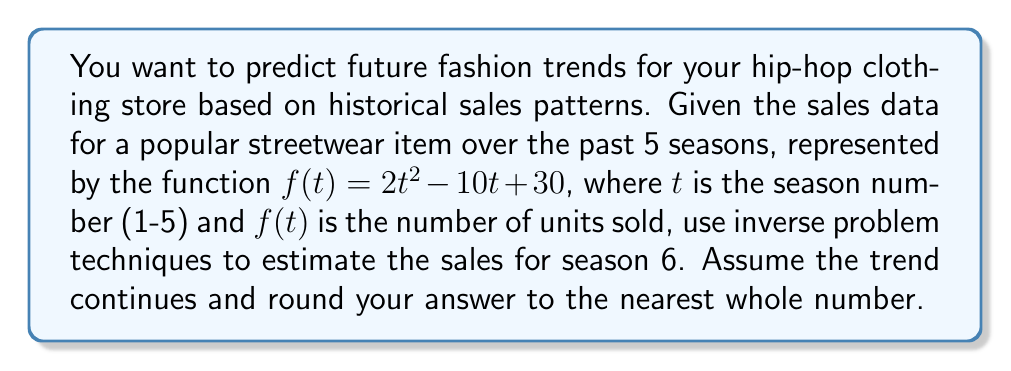Help me with this question. To solve this inverse problem and predict future sales, we'll follow these steps:

1) First, we need to understand the given function:
   $f(t) = 2t^2 - 10t + 30$

2) We're given data for seasons 1-5, so let's extend this to season 6:
   $f(6) = 2(6)^2 - 10(6) + 30$

3) Let's solve this step-by-step:
   $f(6) = 2(36) - 60 + 30$
   $f(6) = 72 - 60 + 30$
   $f(6) = 42$

4) The inverse problem here is to use the known data (seasons 1-5) to predict an unknown value (season 6). We've done this by assuming the quadratic trend continues.

5) Rounding 42 to the nearest whole number doesn't change the value.

Therefore, based on the historical sales pattern, we predict that 42 units of this streetwear item will be sold in season 6.
Answer: 42 units 